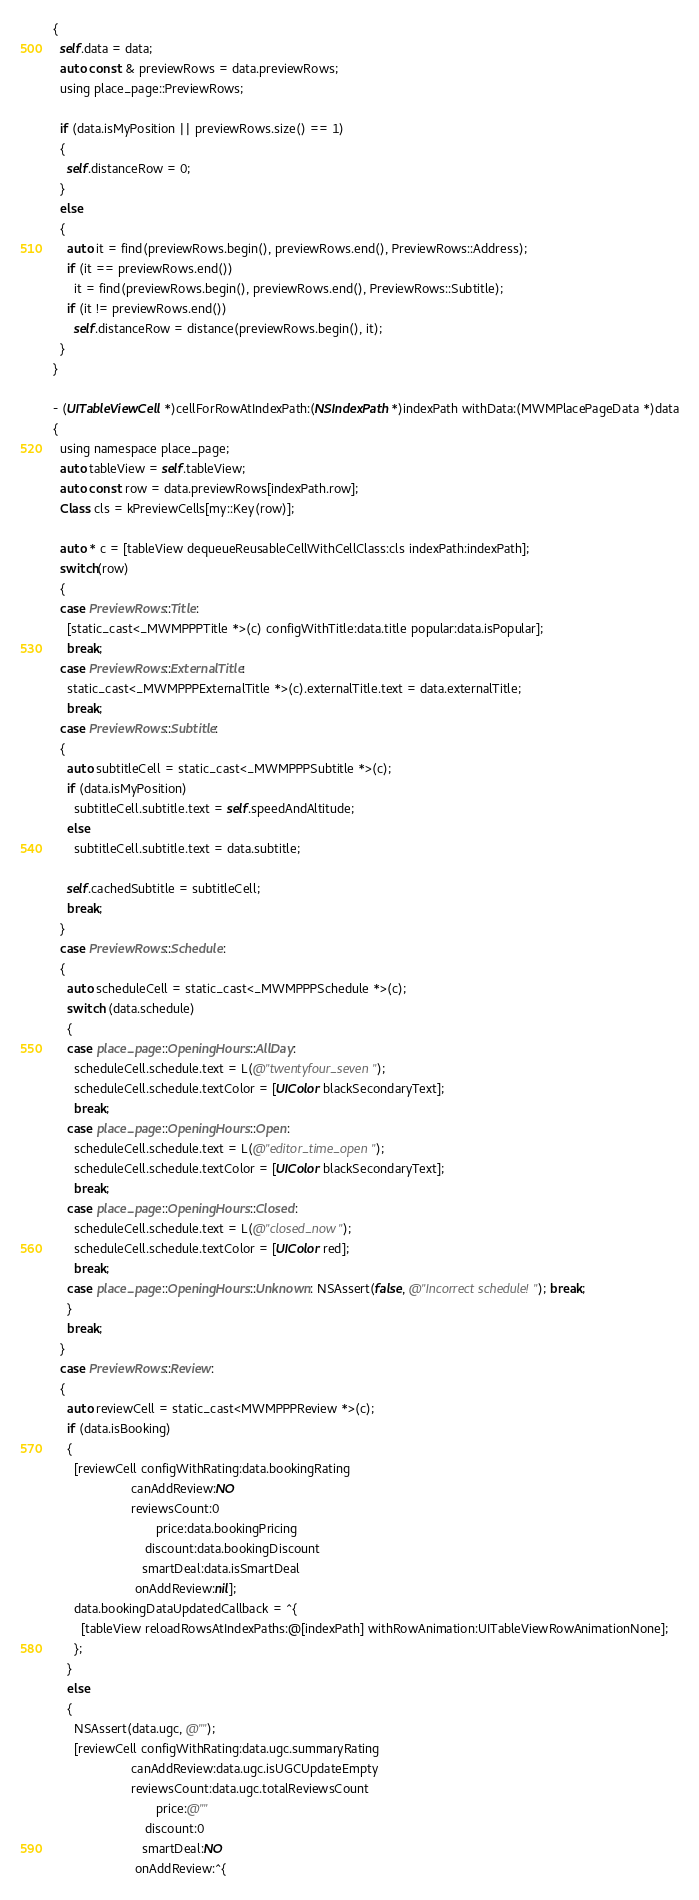<code> <loc_0><loc_0><loc_500><loc_500><_ObjectiveC_>{
  self.data = data;
  auto const & previewRows = data.previewRows;
  using place_page::PreviewRows;

  if (data.isMyPosition || previewRows.size() == 1)
  {
    self.distanceRow = 0;
  }
  else
  {
    auto it = find(previewRows.begin(), previewRows.end(), PreviewRows::Address);
    if (it == previewRows.end())
      it = find(previewRows.begin(), previewRows.end(), PreviewRows::Subtitle);
    if (it != previewRows.end())
      self.distanceRow = distance(previewRows.begin(), it);
  }
}

- (UITableViewCell *)cellForRowAtIndexPath:(NSIndexPath *)indexPath withData:(MWMPlacePageData *)data
{
  using namespace place_page;
  auto tableView = self.tableView;
  auto const row = data.previewRows[indexPath.row];
  Class cls = kPreviewCells[my::Key(row)];

  auto * c = [tableView dequeueReusableCellWithCellClass:cls indexPath:indexPath];
  switch(row)
  {
  case PreviewRows::Title:
    [static_cast<_MWMPPPTitle *>(c) configWithTitle:data.title popular:data.isPopular];
    break;
  case PreviewRows::ExternalTitle:
    static_cast<_MWMPPPExternalTitle *>(c).externalTitle.text = data.externalTitle;
    break;
  case PreviewRows::Subtitle:
  {
    auto subtitleCell = static_cast<_MWMPPPSubtitle *>(c);
    if (data.isMyPosition)
      subtitleCell.subtitle.text = self.speedAndAltitude;
    else
      subtitleCell.subtitle.text = data.subtitle;

    self.cachedSubtitle = subtitleCell;
    break;
  }
  case PreviewRows::Schedule:
  {
    auto scheduleCell = static_cast<_MWMPPPSchedule *>(c);
    switch (data.schedule)
    {
    case place_page::OpeningHours::AllDay:
      scheduleCell.schedule.text = L(@"twentyfour_seven");
      scheduleCell.schedule.textColor = [UIColor blackSecondaryText];
      break;
    case place_page::OpeningHours::Open:
      scheduleCell.schedule.text = L(@"editor_time_open");
      scheduleCell.schedule.textColor = [UIColor blackSecondaryText];
      break;
    case place_page::OpeningHours::Closed:
      scheduleCell.schedule.text = L(@"closed_now");
      scheduleCell.schedule.textColor = [UIColor red];
      break;
    case place_page::OpeningHours::Unknown: NSAssert(false, @"Incorrect schedule!"); break;
    }
    break;
  }
  case PreviewRows::Review:
  {
    auto reviewCell = static_cast<MWMPPPReview *>(c);
    if (data.isBooking)
    {
      [reviewCell configWithRating:data.bookingRating
                      canAddReview:NO
                      reviewsCount:0
                             price:data.bookingPricing
                          discount:data.bookingDiscount
                         smartDeal:data.isSmartDeal
                       onAddReview:nil];
      data.bookingDataUpdatedCallback = ^{
        [tableView reloadRowsAtIndexPaths:@[indexPath] withRowAnimation:UITableViewRowAnimationNone];
      };
    }
    else
    {
      NSAssert(data.ugc, @"");
      [reviewCell configWithRating:data.ugc.summaryRating
                      canAddReview:data.ugc.isUGCUpdateEmpty
                      reviewsCount:data.ugc.totalReviewsCount
                             price:@""
                          discount:0
                         smartDeal:NO
                       onAddReview:^{</code> 